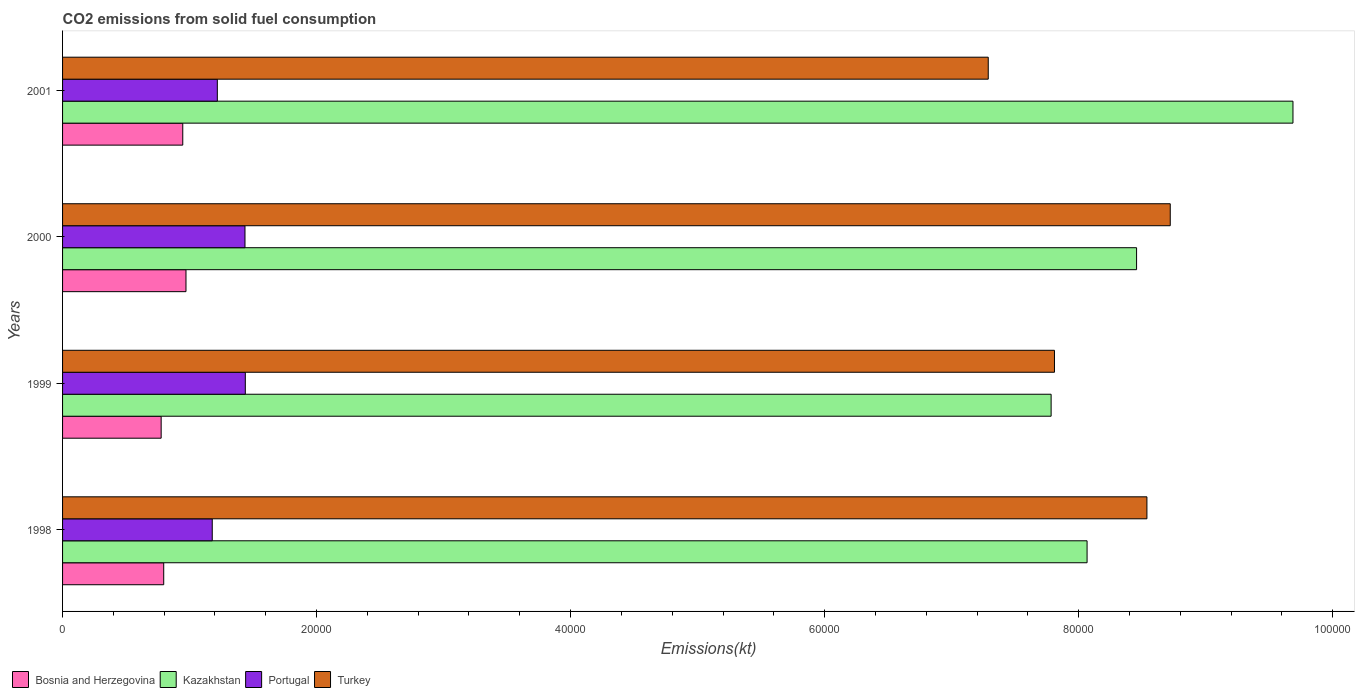How many groups of bars are there?
Provide a succinct answer. 4. Are the number of bars on each tick of the Y-axis equal?
Provide a succinct answer. Yes. How many bars are there on the 2nd tick from the top?
Provide a succinct answer. 4. What is the label of the 4th group of bars from the top?
Offer a very short reply. 1998. What is the amount of CO2 emitted in Bosnia and Herzegovina in 2000?
Your answer should be compact. 9717.55. Across all years, what is the maximum amount of CO2 emitted in Portugal?
Provide a short and direct response. 1.44e+04. Across all years, what is the minimum amount of CO2 emitted in Turkey?
Provide a short and direct response. 7.29e+04. In which year was the amount of CO2 emitted in Kazakhstan minimum?
Offer a terse response. 1999. What is the total amount of CO2 emitted in Bosnia and Herzegovina in the graph?
Provide a short and direct response. 3.49e+04. What is the difference between the amount of CO2 emitted in Bosnia and Herzegovina in 1999 and that in 2001?
Offer a very short reply. -1701.49. What is the difference between the amount of CO2 emitted in Kazakhstan in 1998 and the amount of CO2 emitted in Portugal in 1999?
Provide a short and direct response. 6.63e+04. What is the average amount of CO2 emitted in Portugal per year?
Provide a short and direct response. 1.32e+04. In the year 1998, what is the difference between the amount of CO2 emitted in Kazakhstan and amount of CO2 emitted in Turkey?
Offer a terse response. -4712.1. In how many years, is the amount of CO2 emitted in Turkey greater than 4000 kt?
Your answer should be compact. 4. What is the ratio of the amount of CO2 emitted in Kazakhstan in 1999 to that in 2001?
Your answer should be compact. 0.8. What is the difference between the highest and the second highest amount of CO2 emitted in Turkey?
Your response must be concise. 1837.17. What is the difference between the highest and the lowest amount of CO2 emitted in Portugal?
Offer a very short reply. 2603.57. In how many years, is the amount of CO2 emitted in Kazakhstan greater than the average amount of CO2 emitted in Kazakhstan taken over all years?
Give a very brief answer. 1. Is the sum of the amount of CO2 emitted in Bosnia and Herzegovina in 1999 and 2001 greater than the maximum amount of CO2 emitted in Turkey across all years?
Provide a succinct answer. No. Is it the case that in every year, the sum of the amount of CO2 emitted in Bosnia and Herzegovina and amount of CO2 emitted in Portugal is greater than the sum of amount of CO2 emitted in Kazakhstan and amount of CO2 emitted in Turkey?
Your answer should be very brief. No. What does the 2nd bar from the top in 1999 represents?
Your answer should be compact. Portugal. What does the 1st bar from the bottom in 1998 represents?
Keep it short and to the point. Bosnia and Herzegovina. How many years are there in the graph?
Provide a short and direct response. 4. Are the values on the major ticks of X-axis written in scientific E-notation?
Your answer should be very brief. No. Does the graph contain any zero values?
Offer a very short reply. No. How are the legend labels stacked?
Offer a terse response. Horizontal. What is the title of the graph?
Offer a very short reply. CO2 emissions from solid fuel consumption. What is the label or title of the X-axis?
Give a very brief answer. Emissions(kt). What is the Emissions(kt) in Bosnia and Herzegovina in 1998?
Provide a short and direct response. 7964.72. What is the Emissions(kt) in Kazakhstan in 1998?
Your response must be concise. 8.07e+04. What is the Emissions(kt) in Portugal in 1998?
Offer a very short reply. 1.18e+04. What is the Emissions(kt) in Turkey in 1998?
Provide a succinct answer. 8.54e+04. What is the Emissions(kt) of Bosnia and Herzegovina in 1999?
Give a very brief answer. 7763.04. What is the Emissions(kt) of Kazakhstan in 1999?
Offer a terse response. 7.78e+04. What is the Emissions(kt) in Portugal in 1999?
Your answer should be compact. 1.44e+04. What is the Emissions(kt) in Turkey in 1999?
Offer a terse response. 7.81e+04. What is the Emissions(kt) of Bosnia and Herzegovina in 2000?
Your answer should be compact. 9717.55. What is the Emissions(kt) of Kazakhstan in 2000?
Your answer should be very brief. 8.46e+04. What is the Emissions(kt) of Portugal in 2000?
Give a very brief answer. 1.44e+04. What is the Emissions(kt) of Turkey in 2000?
Offer a terse response. 8.72e+04. What is the Emissions(kt) of Bosnia and Herzegovina in 2001?
Your answer should be compact. 9464.53. What is the Emissions(kt) in Kazakhstan in 2001?
Your answer should be compact. 9.69e+04. What is the Emissions(kt) of Portugal in 2001?
Provide a short and direct response. 1.22e+04. What is the Emissions(kt) in Turkey in 2001?
Offer a very short reply. 7.29e+04. Across all years, what is the maximum Emissions(kt) of Bosnia and Herzegovina?
Your answer should be very brief. 9717.55. Across all years, what is the maximum Emissions(kt) in Kazakhstan?
Offer a terse response. 9.69e+04. Across all years, what is the maximum Emissions(kt) of Portugal?
Provide a short and direct response. 1.44e+04. Across all years, what is the maximum Emissions(kt) of Turkey?
Offer a terse response. 8.72e+04. Across all years, what is the minimum Emissions(kt) of Bosnia and Herzegovina?
Keep it short and to the point. 7763.04. Across all years, what is the minimum Emissions(kt) in Kazakhstan?
Make the answer very short. 7.78e+04. Across all years, what is the minimum Emissions(kt) of Portugal?
Provide a short and direct response. 1.18e+04. Across all years, what is the minimum Emissions(kt) of Turkey?
Your response must be concise. 7.29e+04. What is the total Emissions(kt) of Bosnia and Herzegovina in the graph?
Keep it short and to the point. 3.49e+04. What is the total Emissions(kt) of Kazakhstan in the graph?
Offer a terse response. 3.40e+05. What is the total Emissions(kt) of Portugal in the graph?
Make the answer very short. 5.27e+04. What is the total Emissions(kt) of Turkey in the graph?
Your response must be concise. 3.24e+05. What is the difference between the Emissions(kt) of Bosnia and Herzegovina in 1998 and that in 1999?
Offer a very short reply. 201.69. What is the difference between the Emissions(kt) of Kazakhstan in 1998 and that in 1999?
Provide a succinct answer. 2830.92. What is the difference between the Emissions(kt) in Portugal in 1998 and that in 1999?
Make the answer very short. -2603.57. What is the difference between the Emissions(kt) in Turkey in 1998 and that in 1999?
Your response must be concise. 7278.99. What is the difference between the Emissions(kt) of Bosnia and Herzegovina in 1998 and that in 2000?
Ensure brevity in your answer.  -1752.83. What is the difference between the Emissions(kt) of Kazakhstan in 1998 and that in 2000?
Offer a very short reply. -3898.02. What is the difference between the Emissions(kt) of Portugal in 1998 and that in 2000?
Provide a short and direct response. -2577.9. What is the difference between the Emissions(kt) of Turkey in 1998 and that in 2000?
Ensure brevity in your answer.  -1837.17. What is the difference between the Emissions(kt) of Bosnia and Herzegovina in 1998 and that in 2001?
Make the answer very short. -1499.8. What is the difference between the Emissions(kt) in Kazakhstan in 1998 and that in 2001?
Offer a very short reply. -1.62e+04. What is the difference between the Emissions(kt) in Portugal in 1998 and that in 2001?
Offer a very short reply. -399.7. What is the difference between the Emissions(kt) in Turkey in 1998 and that in 2001?
Your answer should be compact. 1.25e+04. What is the difference between the Emissions(kt) of Bosnia and Herzegovina in 1999 and that in 2000?
Offer a very short reply. -1954.51. What is the difference between the Emissions(kt) of Kazakhstan in 1999 and that in 2000?
Keep it short and to the point. -6728.94. What is the difference between the Emissions(kt) in Portugal in 1999 and that in 2000?
Offer a terse response. 25.67. What is the difference between the Emissions(kt) of Turkey in 1999 and that in 2000?
Provide a short and direct response. -9116.16. What is the difference between the Emissions(kt) in Bosnia and Herzegovina in 1999 and that in 2001?
Your answer should be compact. -1701.49. What is the difference between the Emissions(kt) in Kazakhstan in 1999 and that in 2001?
Your answer should be compact. -1.90e+04. What is the difference between the Emissions(kt) of Portugal in 1999 and that in 2001?
Provide a short and direct response. 2203.87. What is the difference between the Emissions(kt) in Turkey in 1999 and that in 2001?
Make the answer very short. 5214.47. What is the difference between the Emissions(kt) of Bosnia and Herzegovina in 2000 and that in 2001?
Your response must be concise. 253.02. What is the difference between the Emissions(kt) of Kazakhstan in 2000 and that in 2001?
Ensure brevity in your answer.  -1.23e+04. What is the difference between the Emissions(kt) of Portugal in 2000 and that in 2001?
Make the answer very short. 2178.2. What is the difference between the Emissions(kt) of Turkey in 2000 and that in 2001?
Provide a succinct answer. 1.43e+04. What is the difference between the Emissions(kt) in Bosnia and Herzegovina in 1998 and the Emissions(kt) in Kazakhstan in 1999?
Offer a terse response. -6.99e+04. What is the difference between the Emissions(kt) in Bosnia and Herzegovina in 1998 and the Emissions(kt) in Portugal in 1999?
Offer a terse response. -6424.58. What is the difference between the Emissions(kt) of Bosnia and Herzegovina in 1998 and the Emissions(kt) of Turkey in 1999?
Provide a short and direct response. -7.01e+04. What is the difference between the Emissions(kt) in Kazakhstan in 1998 and the Emissions(kt) in Portugal in 1999?
Your response must be concise. 6.63e+04. What is the difference between the Emissions(kt) of Kazakhstan in 1998 and the Emissions(kt) of Turkey in 1999?
Provide a short and direct response. 2566.9. What is the difference between the Emissions(kt) in Portugal in 1998 and the Emissions(kt) in Turkey in 1999?
Provide a succinct answer. -6.63e+04. What is the difference between the Emissions(kt) in Bosnia and Herzegovina in 1998 and the Emissions(kt) in Kazakhstan in 2000?
Your answer should be very brief. -7.66e+04. What is the difference between the Emissions(kt) in Bosnia and Herzegovina in 1998 and the Emissions(kt) in Portugal in 2000?
Your response must be concise. -6398.91. What is the difference between the Emissions(kt) of Bosnia and Herzegovina in 1998 and the Emissions(kt) of Turkey in 2000?
Your response must be concise. -7.93e+04. What is the difference between the Emissions(kt) of Kazakhstan in 1998 and the Emissions(kt) of Portugal in 2000?
Your answer should be compact. 6.63e+04. What is the difference between the Emissions(kt) of Kazakhstan in 1998 and the Emissions(kt) of Turkey in 2000?
Your answer should be compact. -6549.26. What is the difference between the Emissions(kt) in Portugal in 1998 and the Emissions(kt) in Turkey in 2000?
Offer a very short reply. -7.54e+04. What is the difference between the Emissions(kt) in Bosnia and Herzegovina in 1998 and the Emissions(kt) in Kazakhstan in 2001?
Your response must be concise. -8.89e+04. What is the difference between the Emissions(kt) in Bosnia and Herzegovina in 1998 and the Emissions(kt) in Portugal in 2001?
Make the answer very short. -4220.72. What is the difference between the Emissions(kt) in Bosnia and Herzegovina in 1998 and the Emissions(kt) in Turkey in 2001?
Offer a very short reply. -6.49e+04. What is the difference between the Emissions(kt) of Kazakhstan in 1998 and the Emissions(kt) of Portugal in 2001?
Keep it short and to the point. 6.85e+04. What is the difference between the Emissions(kt) of Kazakhstan in 1998 and the Emissions(kt) of Turkey in 2001?
Provide a succinct answer. 7781.37. What is the difference between the Emissions(kt) of Portugal in 1998 and the Emissions(kt) of Turkey in 2001?
Offer a terse response. -6.11e+04. What is the difference between the Emissions(kt) of Bosnia and Herzegovina in 1999 and the Emissions(kt) of Kazakhstan in 2000?
Ensure brevity in your answer.  -7.68e+04. What is the difference between the Emissions(kt) of Bosnia and Herzegovina in 1999 and the Emissions(kt) of Portugal in 2000?
Provide a succinct answer. -6600.6. What is the difference between the Emissions(kt) of Bosnia and Herzegovina in 1999 and the Emissions(kt) of Turkey in 2000?
Provide a succinct answer. -7.95e+04. What is the difference between the Emissions(kt) in Kazakhstan in 1999 and the Emissions(kt) in Portugal in 2000?
Offer a terse response. 6.35e+04. What is the difference between the Emissions(kt) in Kazakhstan in 1999 and the Emissions(kt) in Turkey in 2000?
Provide a short and direct response. -9380.19. What is the difference between the Emissions(kt) in Portugal in 1999 and the Emissions(kt) in Turkey in 2000?
Give a very brief answer. -7.28e+04. What is the difference between the Emissions(kt) of Bosnia and Herzegovina in 1999 and the Emissions(kt) of Kazakhstan in 2001?
Provide a succinct answer. -8.91e+04. What is the difference between the Emissions(kt) of Bosnia and Herzegovina in 1999 and the Emissions(kt) of Portugal in 2001?
Your answer should be very brief. -4422.4. What is the difference between the Emissions(kt) in Bosnia and Herzegovina in 1999 and the Emissions(kt) in Turkey in 2001?
Offer a terse response. -6.51e+04. What is the difference between the Emissions(kt) of Kazakhstan in 1999 and the Emissions(kt) of Portugal in 2001?
Offer a terse response. 6.57e+04. What is the difference between the Emissions(kt) in Kazakhstan in 1999 and the Emissions(kt) in Turkey in 2001?
Make the answer very short. 4950.45. What is the difference between the Emissions(kt) in Portugal in 1999 and the Emissions(kt) in Turkey in 2001?
Provide a succinct answer. -5.85e+04. What is the difference between the Emissions(kt) of Bosnia and Herzegovina in 2000 and the Emissions(kt) of Kazakhstan in 2001?
Make the answer very short. -8.72e+04. What is the difference between the Emissions(kt) in Bosnia and Herzegovina in 2000 and the Emissions(kt) in Portugal in 2001?
Your answer should be compact. -2467.89. What is the difference between the Emissions(kt) in Bosnia and Herzegovina in 2000 and the Emissions(kt) in Turkey in 2001?
Make the answer very short. -6.32e+04. What is the difference between the Emissions(kt) of Kazakhstan in 2000 and the Emissions(kt) of Portugal in 2001?
Make the answer very short. 7.24e+04. What is the difference between the Emissions(kt) in Kazakhstan in 2000 and the Emissions(kt) in Turkey in 2001?
Your answer should be very brief. 1.17e+04. What is the difference between the Emissions(kt) in Portugal in 2000 and the Emissions(kt) in Turkey in 2001?
Offer a very short reply. -5.85e+04. What is the average Emissions(kt) of Bosnia and Herzegovina per year?
Your response must be concise. 8727.46. What is the average Emissions(kt) of Kazakhstan per year?
Provide a succinct answer. 8.50e+04. What is the average Emissions(kt) of Portugal per year?
Offer a very short reply. 1.32e+04. What is the average Emissions(kt) of Turkey per year?
Ensure brevity in your answer.  8.09e+04. In the year 1998, what is the difference between the Emissions(kt) in Bosnia and Herzegovina and Emissions(kt) in Kazakhstan?
Your answer should be very brief. -7.27e+04. In the year 1998, what is the difference between the Emissions(kt) of Bosnia and Herzegovina and Emissions(kt) of Portugal?
Keep it short and to the point. -3821.01. In the year 1998, what is the difference between the Emissions(kt) of Bosnia and Herzegovina and Emissions(kt) of Turkey?
Offer a very short reply. -7.74e+04. In the year 1998, what is the difference between the Emissions(kt) in Kazakhstan and Emissions(kt) in Portugal?
Your answer should be very brief. 6.89e+04. In the year 1998, what is the difference between the Emissions(kt) in Kazakhstan and Emissions(kt) in Turkey?
Offer a very short reply. -4712.1. In the year 1998, what is the difference between the Emissions(kt) of Portugal and Emissions(kt) of Turkey?
Provide a short and direct response. -7.36e+04. In the year 1999, what is the difference between the Emissions(kt) in Bosnia and Herzegovina and Emissions(kt) in Kazakhstan?
Your response must be concise. -7.01e+04. In the year 1999, what is the difference between the Emissions(kt) of Bosnia and Herzegovina and Emissions(kt) of Portugal?
Offer a very short reply. -6626.27. In the year 1999, what is the difference between the Emissions(kt) in Bosnia and Herzegovina and Emissions(kt) in Turkey?
Ensure brevity in your answer.  -7.03e+04. In the year 1999, what is the difference between the Emissions(kt) in Kazakhstan and Emissions(kt) in Portugal?
Offer a very short reply. 6.34e+04. In the year 1999, what is the difference between the Emissions(kt) of Kazakhstan and Emissions(kt) of Turkey?
Your answer should be very brief. -264.02. In the year 1999, what is the difference between the Emissions(kt) in Portugal and Emissions(kt) in Turkey?
Make the answer very short. -6.37e+04. In the year 2000, what is the difference between the Emissions(kt) in Bosnia and Herzegovina and Emissions(kt) in Kazakhstan?
Your response must be concise. -7.48e+04. In the year 2000, what is the difference between the Emissions(kt) in Bosnia and Herzegovina and Emissions(kt) in Portugal?
Provide a short and direct response. -4646.09. In the year 2000, what is the difference between the Emissions(kt) of Bosnia and Herzegovina and Emissions(kt) of Turkey?
Ensure brevity in your answer.  -7.75e+04. In the year 2000, what is the difference between the Emissions(kt) in Kazakhstan and Emissions(kt) in Portugal?
Give a very brief answer. 7.02e+04. In the year 2000, what is the difference between the Emissions(kt) of Kazakhstan and Emissions(kt) of Turkey?
Offer a terse response. -2651.24. In the year 2000, what is the difference between the Emissions(kt) in Portugal and Emissions(kt) in Turkey?
Give a very brief answer. -7.29e+04. In the year 2001, what is the difference between the Emissions(kt) of Bosnia and Herzegovina and Emissions(kt) of Kazakhstan?
Offer a very short reply. -8.74e+04. In the year 2001, what is the difference between the Emissions(kt) in Bosnia and Herzegovina and Emissions(kt) in Portugal?
Make the answer very short. -2720.91. In the year 2001, what is the difference between the Emissions(kt) in Bosnia and Herzegovina and Emissions(kt) in Turkey?
Offer a very short reply. -6.34e+04. In the year 2001, what is the difference between the Emissions(kt) in Kazakhstan and Emissions(kt) in Portugal?
Make the answer very short. 8.47e+04. In the year 2001, what is the difference between the Emissions(kt) of Kazakhstan and Emissions(kt) of Turkey?
Your response must be concise. 2.40e+04. In the year 2001, what is the difference between the Emissions(kt) in Portugal and Emissions(kt) in Turkey?
Offer a very short reply. -6.07e+04. What is the ratio of the Emissions(kt) of Kazakhstan in 1998 to that in 1999?
Offer a terse response. 1.04. What is the ratio of the Emissions(kt) in Portugal in 1998 to that in 1999?
Your answer should be compact. 0.82. What is the ratio of the Emissions(kt) in Turkey in 1998 to that in 1999?
Offer a terse response. 1.09. What is the ratio of the Emissions(kt) in Bosnia and Herzegovina in 1998 to that in 2000?
Provide a short and direct response. 0.82. What is the ratio of the Emissions(kt) in Kazakhstan in 1998 to that in 2000?
Your answer should be very brief. 0.95. What is the ratio of the Emissions(kt) of Portugal in 1998 to that in 2000?
Offer a very short reply. 0.82. What is the ratio of the Emissions(kt) in Turkey in 1998 to that in 2000?
Your answer should be compact. 0.98. What is the ratio of the Emissions(kt) in Bosnia and Herzegovina in 1998 to that in 2001?
Make the answer very short. 0.84. What is the ratio of the Emissions(kt) in Kazakhstan in 1998 to that in 2001?
Keep it short and to the point. 0.83. What is the ratio of the Emissions(kt) of Portugal in 1998 to that in 2001?
Offer a terse response. 0.97. What is the ratio of the Emissions(kt) of Turkey in 1998 to that in 2001?
Your answer should be compact. 1.17. What is the ratio of the Emissions(kt) in Bosnia and Herzegovina in 1999 to that in 2000?
Provide a succinct answer. 0.8. What is the ratio of the Emissions(kt) of Kazakhstan in 1999 to that in 2000?
Your answer should be compact. 0.92. What is the ratio of the Emissions(kt) in Turkey in 1999 to that in 2000?
Provide a short and direct response. 0.9. What is the ratio of the Emissions(kt) of Bosnia and Herzegovina in 1999 to that in 2001?
Provide a short and direct response. 0.82. What is the ratio of the Emissions(kt) in Kazakhstan in 1999 to that in 2001?
Make the answer very short. 0.8. What is the ratio of the Emissions(kt) of Portugal in 1999 to that in 2001?
Keep it short and to the point. 1.18. What is the ratio of the Emissions(kt) in Turkey in 1999 to that in 2001?
Ensure brevity in your answer.  1.07. What is the ratio of the Emissions(kt) of Bosnia and Herzegovina in 2000 to that in 2001?
Offer a very short reply. 1.03. What is the ratio of the Emissions(kt) of Kazakhstan in 2000 to that in 2001?
Provide a succinct answer. 0.87. What is the ratio of the Emissions(kt) of Portugal in 2000 to that in 2001?
Your response must be concise. 1.18. What is the ratio of the Emissions(kt) of Turkey in 2000 to that in 2001?
Give a very brief answer. 1.2. What is the difference between the highest and the second highest Emissions(kt) of Bosnia and Herzegovina?
Give a very brief answer. 253.02. What is the difference between the highest and the second highest Emissions(kt) in Kazakhstan?
Offer a terse response. 1.23e+04. What is the difference between the highest and the second highest Emissions(kt) in Portugal?
Offer a very short reply. 25.67. What is the difference between the highest and the second highest Emissions(kt) in Turkey?
Your response must be concise. 1837.17. What is the difference between the highest and the lowest Emissions(kt) of Bosnia and Herzegovina?
Provide a succinct answer. 1954.51. What is the difference between the highest and the lowest Emissions(kt) in Kazakhstan?
Offer a very short reply. 1.90e+04. What is the difference between the highest and the lowest Emissions(kt) in Portugal?
Make the answer very short. 2603.57. What is the difference between the highest and the lowest Emissions(kt) of Turkey?
Your answer should be very brief. 1.43e+04. 